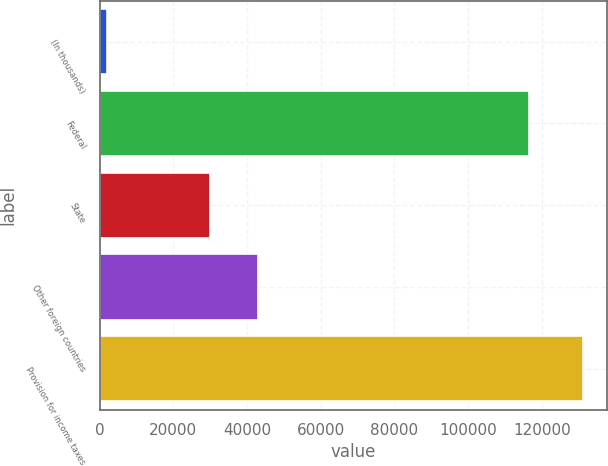Convert chart to OTSL. <chart><loc_0><loc_0><loc_500><loc_500><bar_chart><fcel>(In thousands)<fcel>Federal<fcel>State<fcel>Other foreign countries<fcel>Provision for income taxes<nl><fcel>2016<fcel>116637<fcel>29989<fcel>42917.7<fcel>131303<nl></chart> 